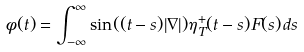Convert formula to latex. <formula><loc_0><loc_0><loc_500><loc_500>\phi ( t ) = \int _ { - \infty } ^ { \infty } \sin ( ( t - s ) | \nabla | ) \eta _ { T } ^ { + } ( t - s ) F ( s ) \, d s</formula> 